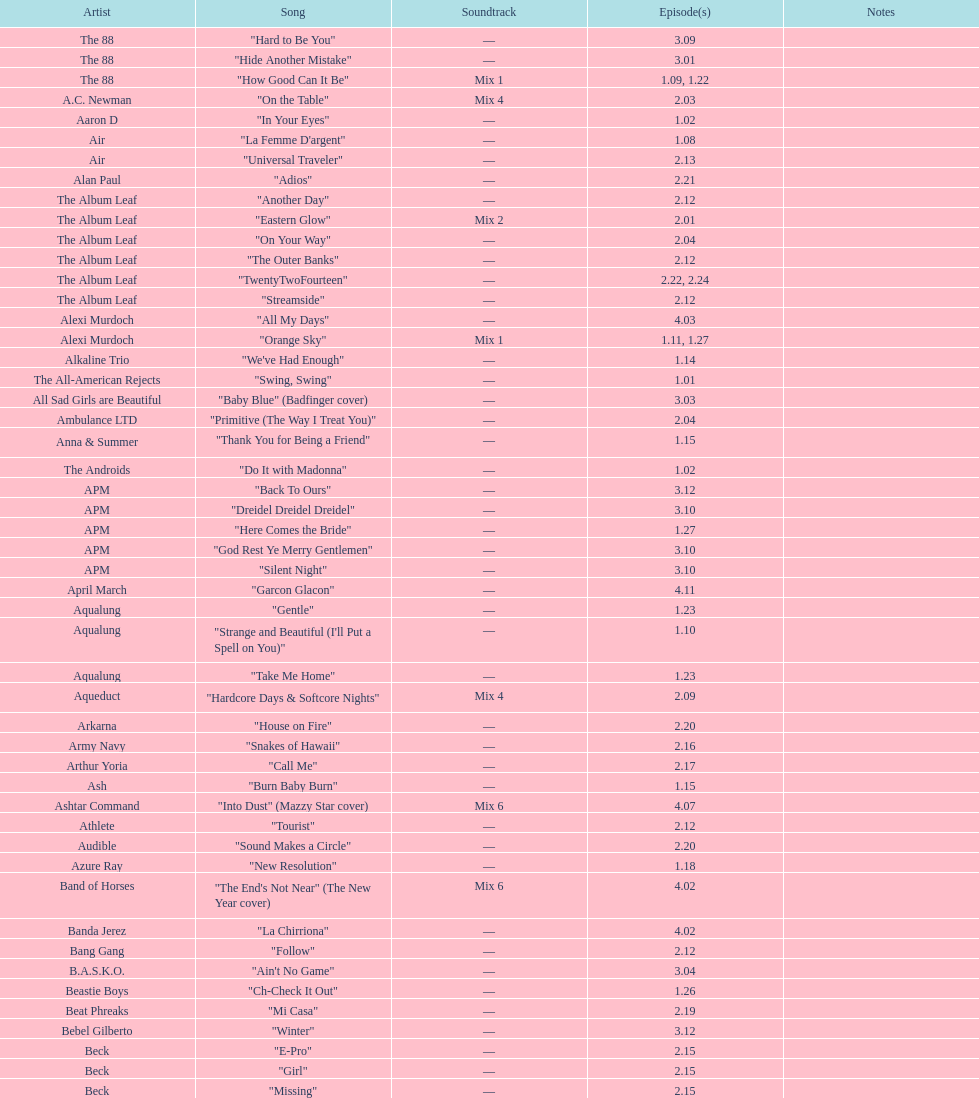Who is the artist behind "girl" and "el pro"? Beck. 